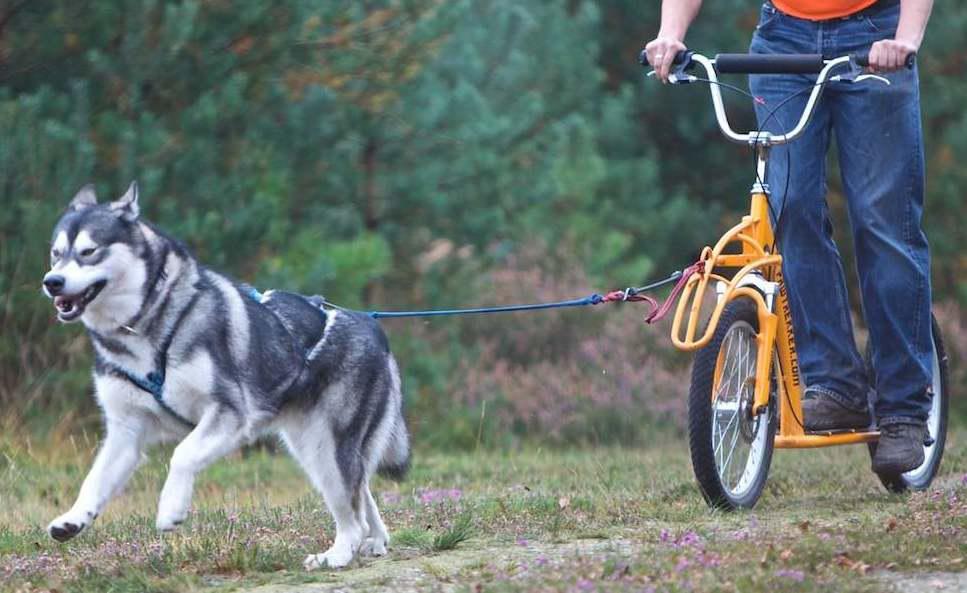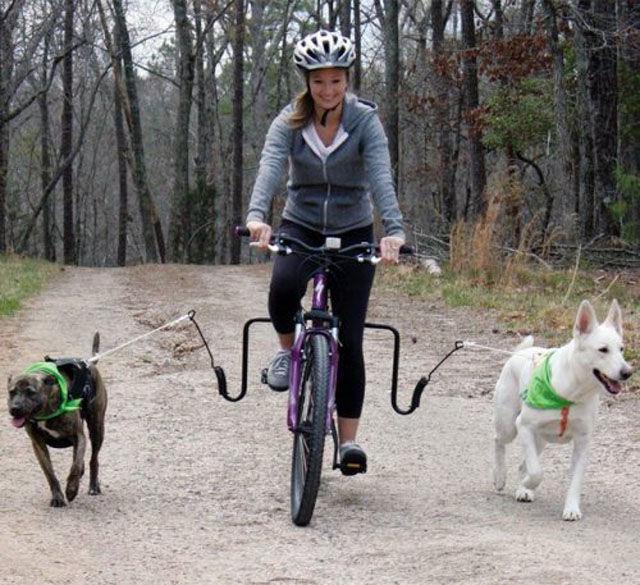The first image is the image on the left, the second image is the image on the right. Analyze the images presented: Is the assertion "Someone is riding a bike while dogs run with them." valid? Answer yes or no. Yes. The first image is the image on the left, the second image is the image on the right. Evaluate the accuracy of this statement regarding the images: "At least one image shows sled dogs moving across a snowy ground.". Is it true? Answer yes or no. No. 